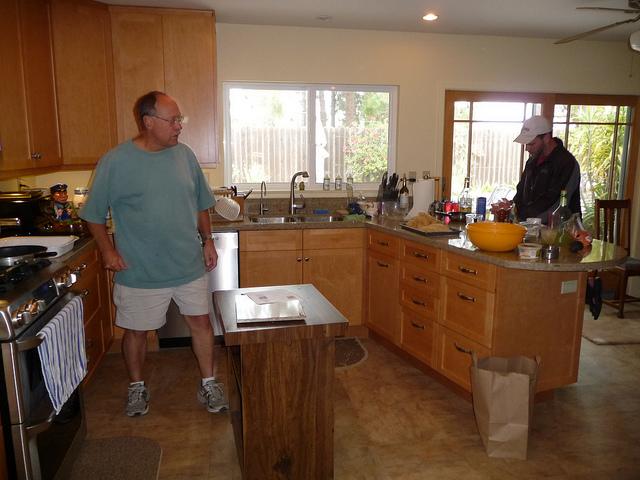Is the wood shiny?
Short answer required. No. Are the windows facing the front yard?
Be succinct. No. What color is the large bowl on the counter?
Be succinct. Yellow. 